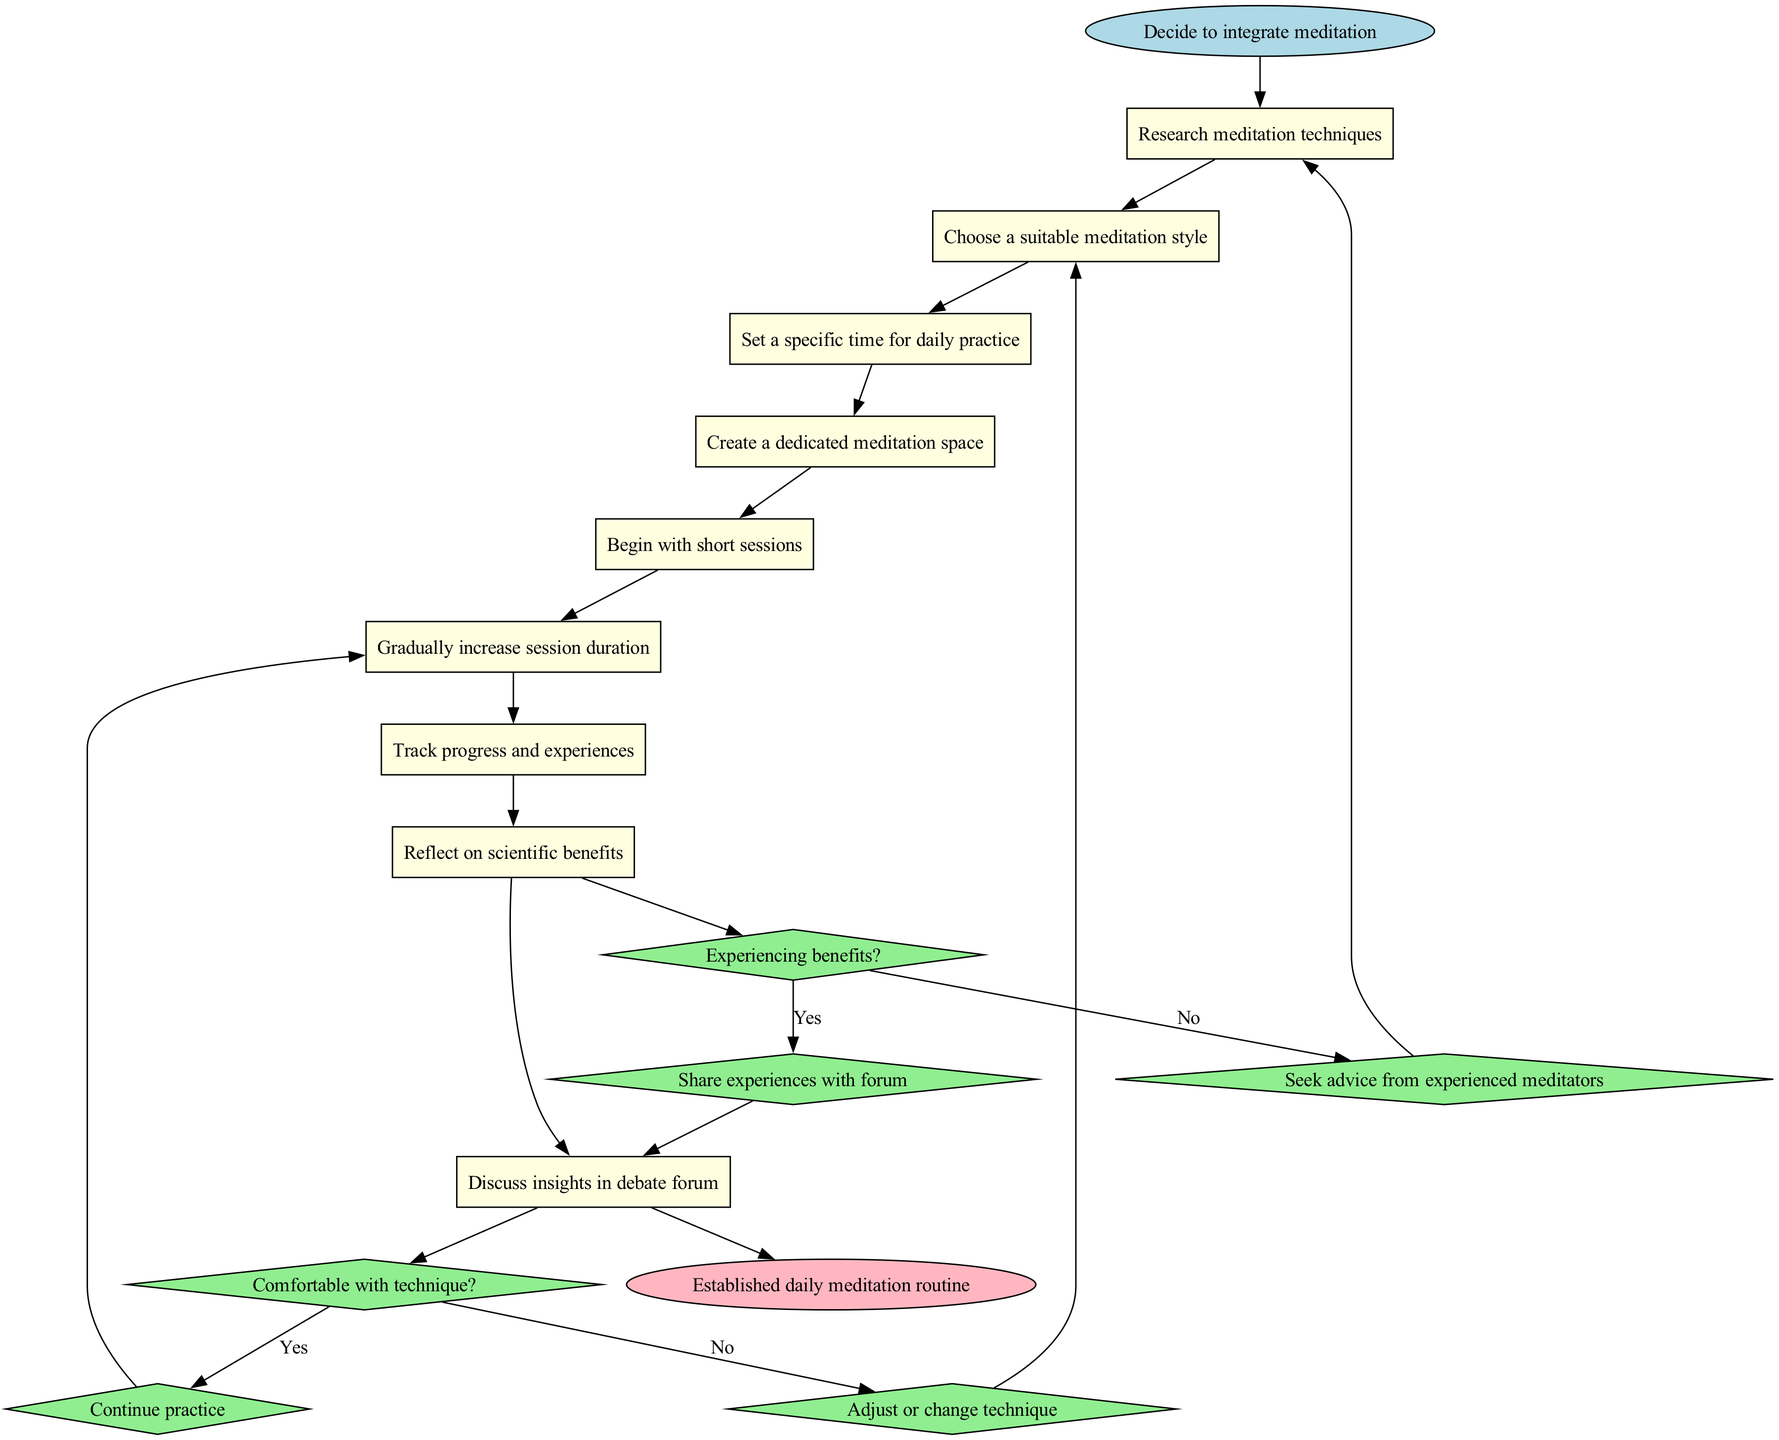What is the starting node of the diagram? The diagram begins with the node labeled "Decide to integrate meditation."
Answer: Decide to integrate meditation How many activities are listed in the diagram? The diagram contains a total of 8 activities related to integrating meditation practices.
Answer: 8 What is the first activity after the starting node? The first activity that follows the starting node is "Research meditation techniques."
Answer: Research meditation techniques What happens if a person is not comfortable with the technique? If the person is not comfortable with the technique, they will "Adjust or change technique" according to the decision node.
Answer: Adjust or change technique Which activity directly leads to reflecting on scientific benefits? The activity that leads to reflecting on scientific benefits is "Track progress and experiences."
Answer: Track progress and experiences What is the last node that leads to the end of the diagram? The last node that connects to the end of the diagram is "Discuss insights in debate forum."
Answer: Discuss insights in debate forum If someone experiences benefits, what is the next step according to the diagram? If benefits are experienced, the next step is to "Share experiences with forum."
Answer: Share experiences with forum What is the main goal indicated at the end of the diagram? The diagram indicates that the main goal is to have an "Established daily meditation routine."
Answer: Established daily meditation routine How does the decision about experiencing benefits influence the flow of activities? Depending on whether benefits are experienced, the flow diverges to either sharing experiences or seeking advice, thus affecting the direction and subsequent activities.
Answer: Sharing experiences or seeking advice 